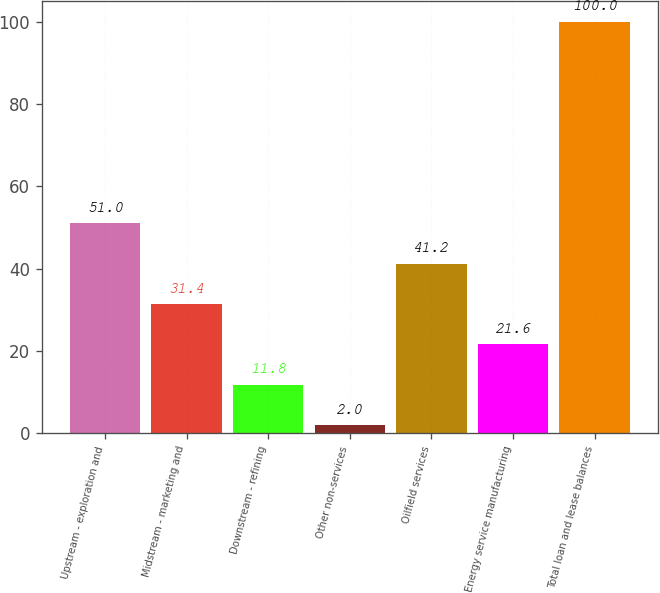<chart> <loc_0><loc_0><loc_500><loc_500><bar_chart><fcel>Upstream - exploration and<fcel>Midstream - marketing and<fcel>Downstream - refining<fcel>Other non-services<fcel>Oilfield services<fcel>Energy service manufacturing<fcel>Total loan and lease balances<nl><fcel>51<fcel>31.4<fcel>11.8<fcel>2<fcel>41.2<fcel>21.6<fcel>100<nl></chart> 